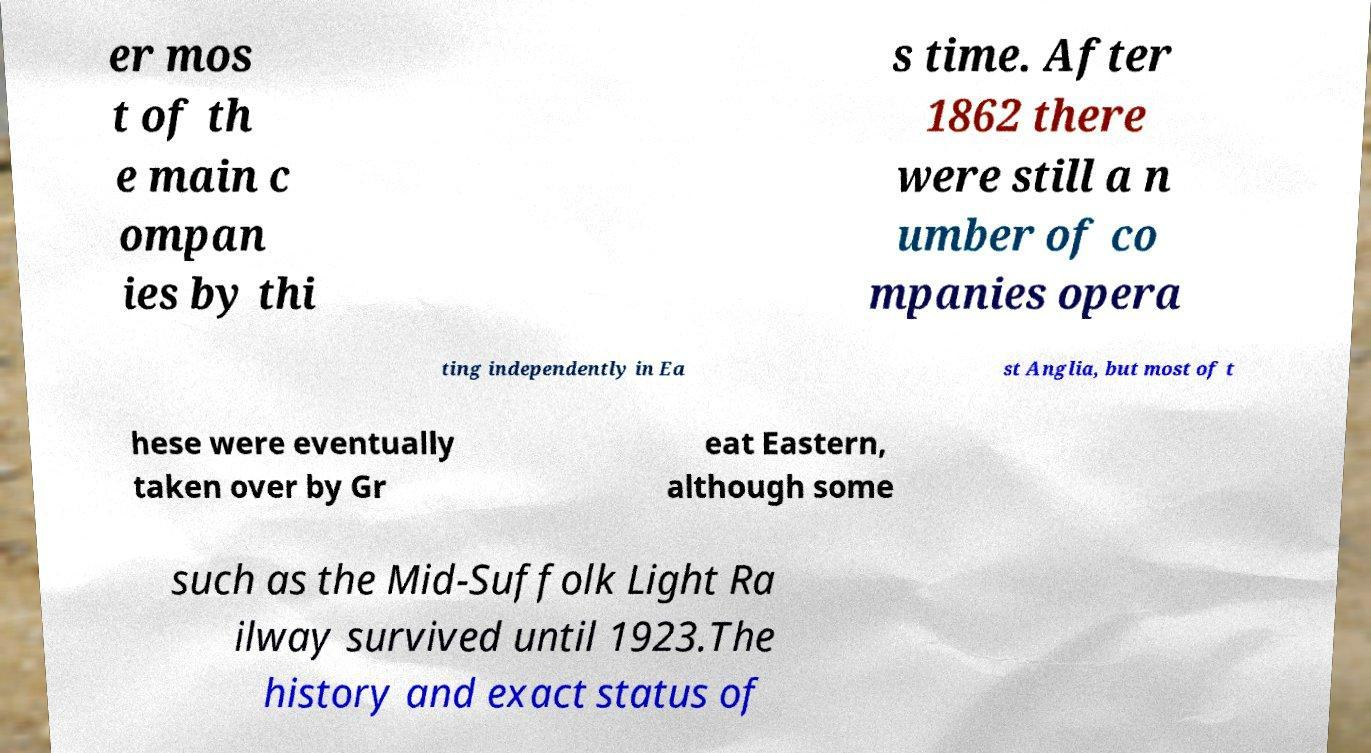What messages or text are displayed in this image? I need them in a readable, typed format. er mos t of th e main c ompan ies by thi s time. After 1862 there were still a n umber of co mpanies opera ting independently in Ea st Anglia, but most of t hese were eventually taken over by Gr eat Eastern, although some such as the Mid-Suffolk Light Ra ilway survived until 1923.The history and exact status of 